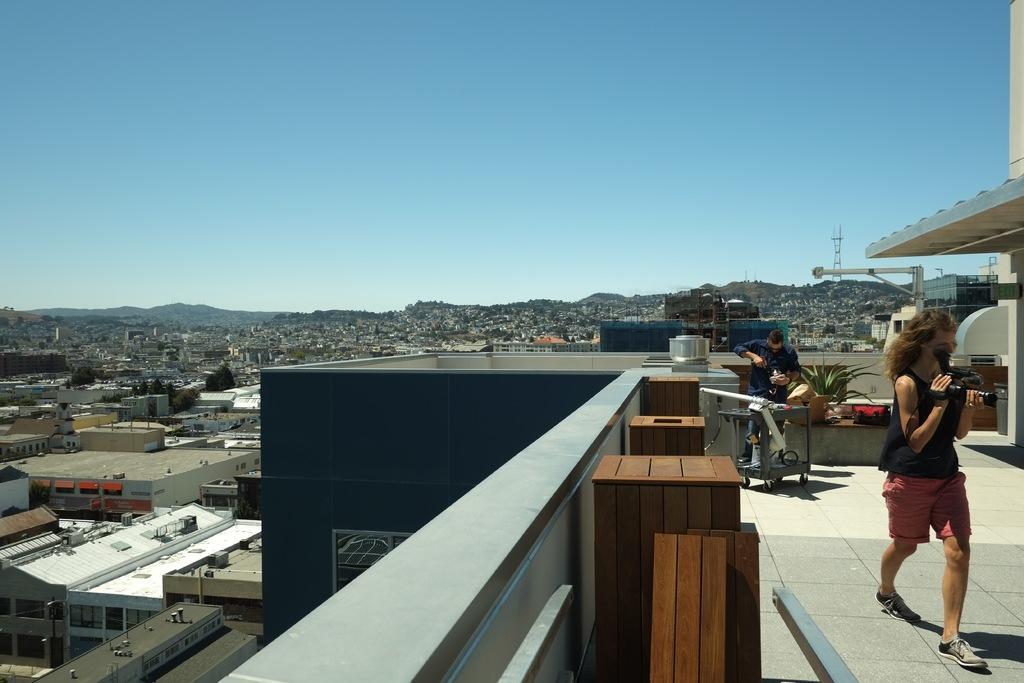Can you describe this image briefly? On the right side of the image there are two people holding some objects and they are standing on the building. There are tables, flower pot and a few other objects. In the background of the image there are buildings, trees, towers and mountains. At the top of the image there is sky. 